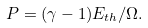Convert formula to latex. <formula><loc_0><loc_0><loc_500><loc_500>P = ( \gamma - 1 ) E _ { t h } / \Omega .</formula> 